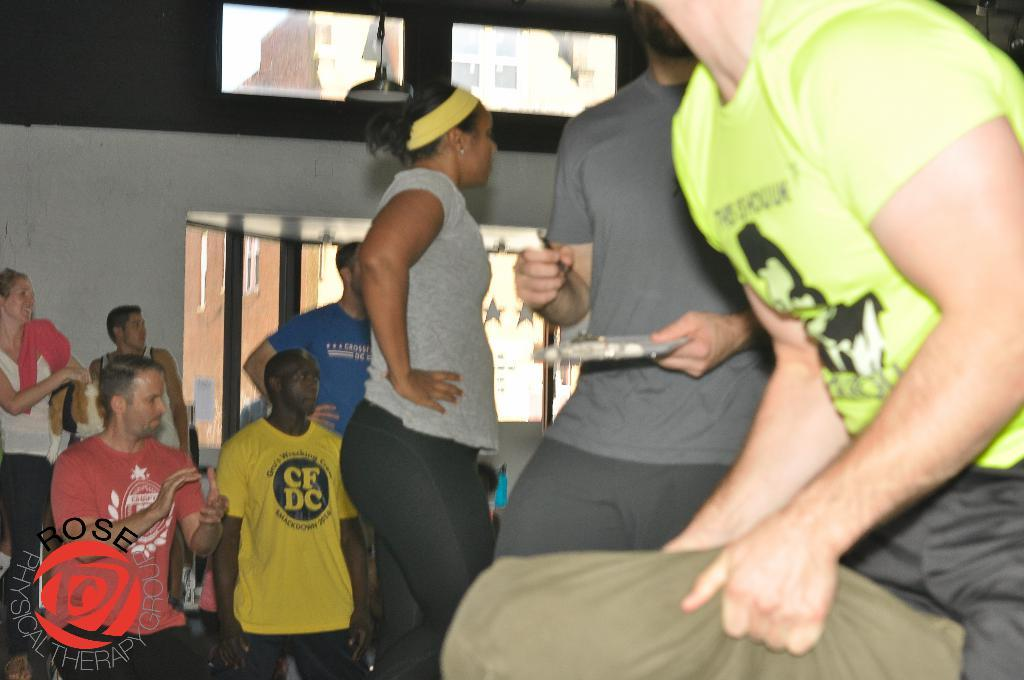What type of structure can be seen in the image? There is a wall in the image. What architectural feature is present in the wall? There are windows in the image. Can you describe the people present in the image? There are people present in the image. What type of comfort can be seen in the image? There is no specific comfort depicted in the image; it features a wall, windows, and people. What discovery was made by the people in the image? There is no indication of a discovery being made by the people in the image. 